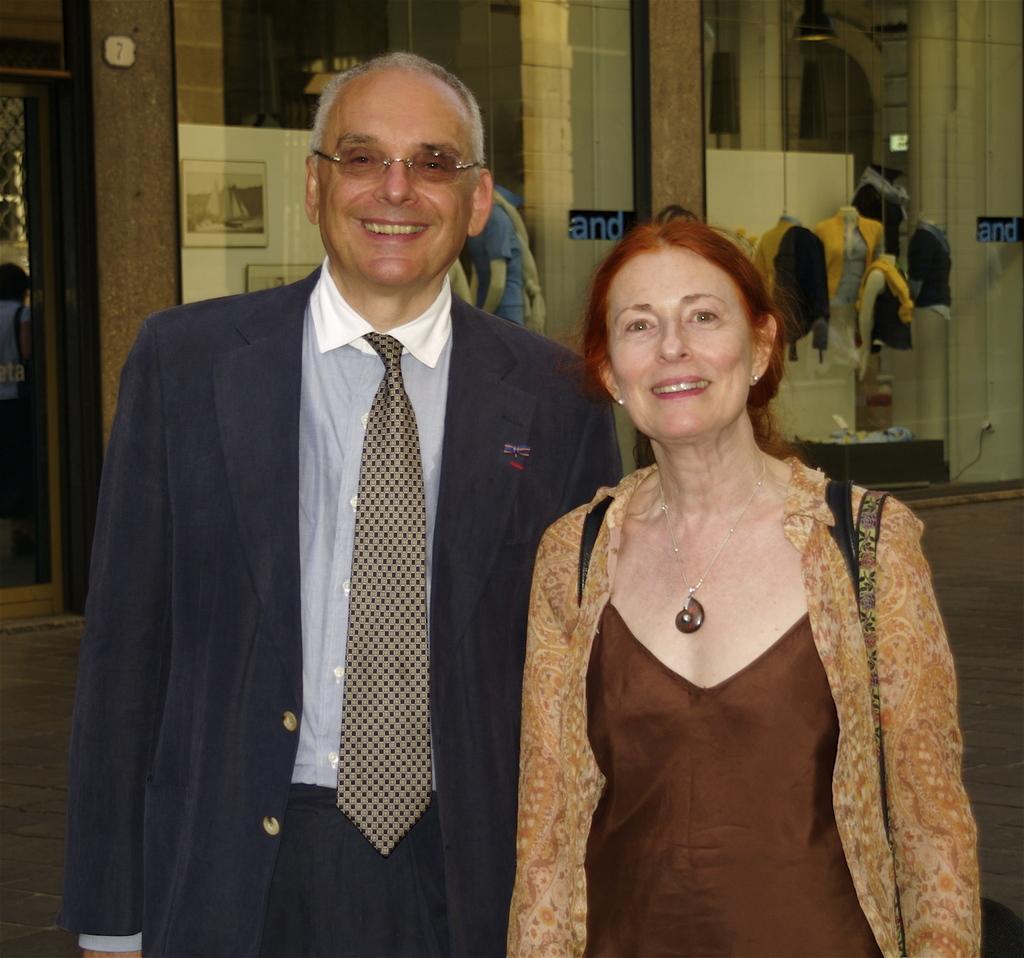Please provide a concise description of this image. In the center of the image we can see a man and a lady standing and smiling. In the background there is a wall and we can see a glass doors. There are mannequins and we can see clothes placed on the mannequins. On the left there is a person. 